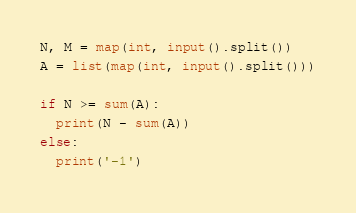<code> <loc_0><loc_0><loc_500><loc_500><_Python_>N, M = map(int, input().split())
A = list(map(int, input().split()))

if N >= sum(A):
  print(N - sum(A))
else:
  print('-1')
</code> 